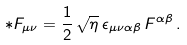Convert formula to latex. <formula><loc_0><loc_0><loc_500><loc_500>* F _ { \mu \nu } = \frac { 1 } { 2 } \, \sqrt { \eta } \, \epsilon _ { \mu \nu \alpha \beta } \, F ^ { \alpha \beta } \, .</formula> 